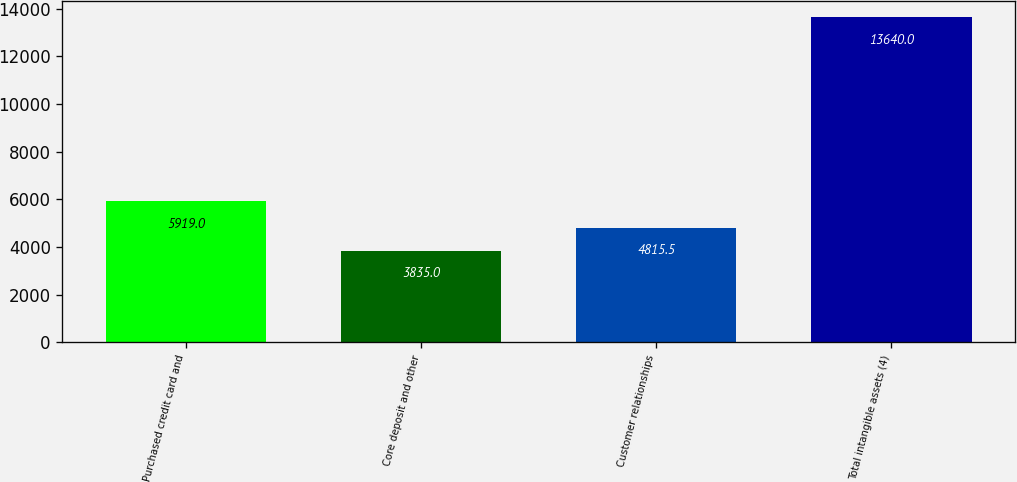Convert chart. <chart><loc_0><loc_0><loc_500><loc_500><bar_chart><fcel>Purchased credit card and<fcel>Core deposit and other<fcel>Customer relationships<fcel>Total intangible assets (4)<nl><fcel>5919<fcel>3835<fcel>4815.5<fcel>13640<nl></chart> 